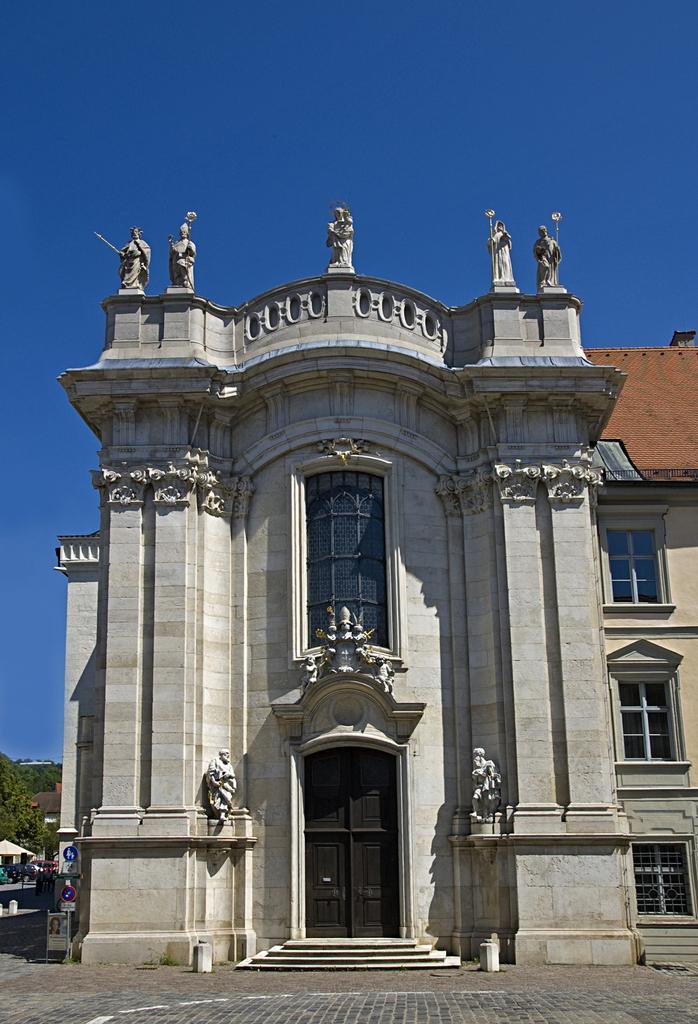How would you summarize this image in a sentence or two? In this image I can see the buildings. On one of the building I can see the statues. To the side there are boards, poles and the trees. In the background I can see the blue sky. 